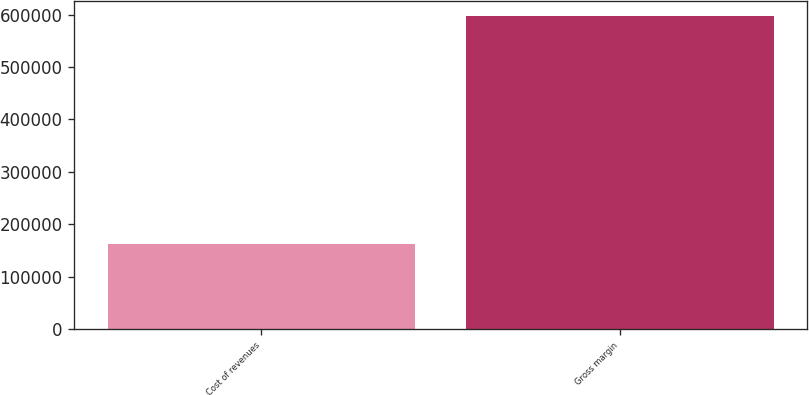Convert chart to OTSL. <chart><loc_0><loc_0><loc_500><loc_500><bar_chart><fcel>Cost of revenues<fcel>Gross margin<nl><fcel>162228<fcel>596535<nl></chart> 